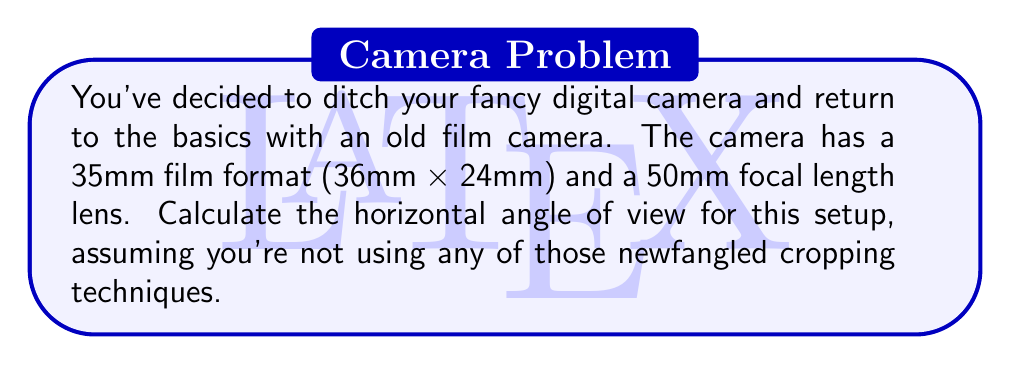Can you solve this math problem? To calculate the horizontal angle of view, we'll use the following steps:

1. Identify the relevant formula:
   $$\text{Angle of View} = 2 \times \arctan(\frac{\text{frame size}}{2 \times \text{focal length}})$$

2. Determine the horizontal frame size:
   The 35mm film format has a horizontal dimension of 36mm.

3. Use the given focal length:
   The lens has a focal length of 50mm.

4. Plug the values into the formula:
   $$\text{Angle of View} = 2 \times \arctan(\frac{36\text{mm}}{2 \times 50\text{mm}})$$

5. Simplify:
   $$\text{Angle of View} = 2 \times \arctan(\frac{18}{50})$$

6. Calculate:
   $$\text{Angle of View} = 2 \times \arctan(0.36)$$
   $$\text{Angle of View} = 2 \times 19.79°$$
   $$\text{Angle of View} = 39.58°$$

7. Round to two decimal places:
   $$\text{Angle of View} \approx 39.60°$$

[asy]
import geometry;

size(200);
pair O=(0,0);
real theta = 39.60*pi/180;
draw(O--100*(cos(theta/2),sin(theta/2)));
draw(O--100*(cos(theta/2),-sin(theta/2)));
draw(arc(O,100,0,theta*180/pi),Arrow);
label("39.60°",50*(cos(theta/4),0),S);
[/asy]
Answer: 39.60° 